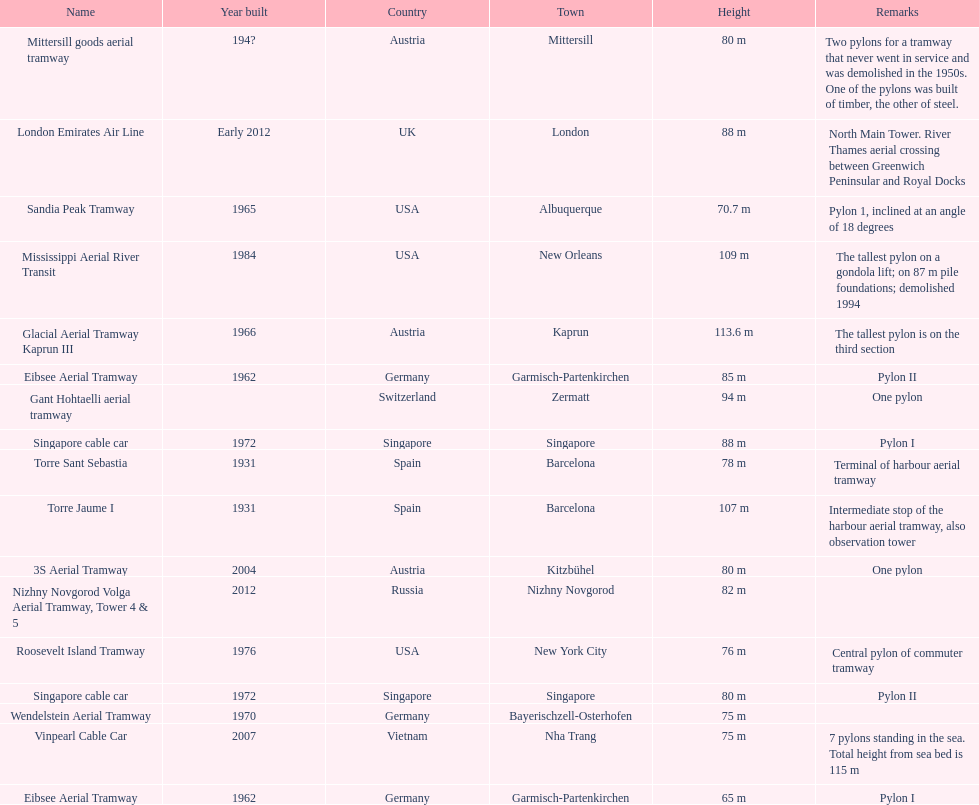List two pylons that are at most, 80 m in height. Mittersill goods aerial tramway, Singapore cable car. 